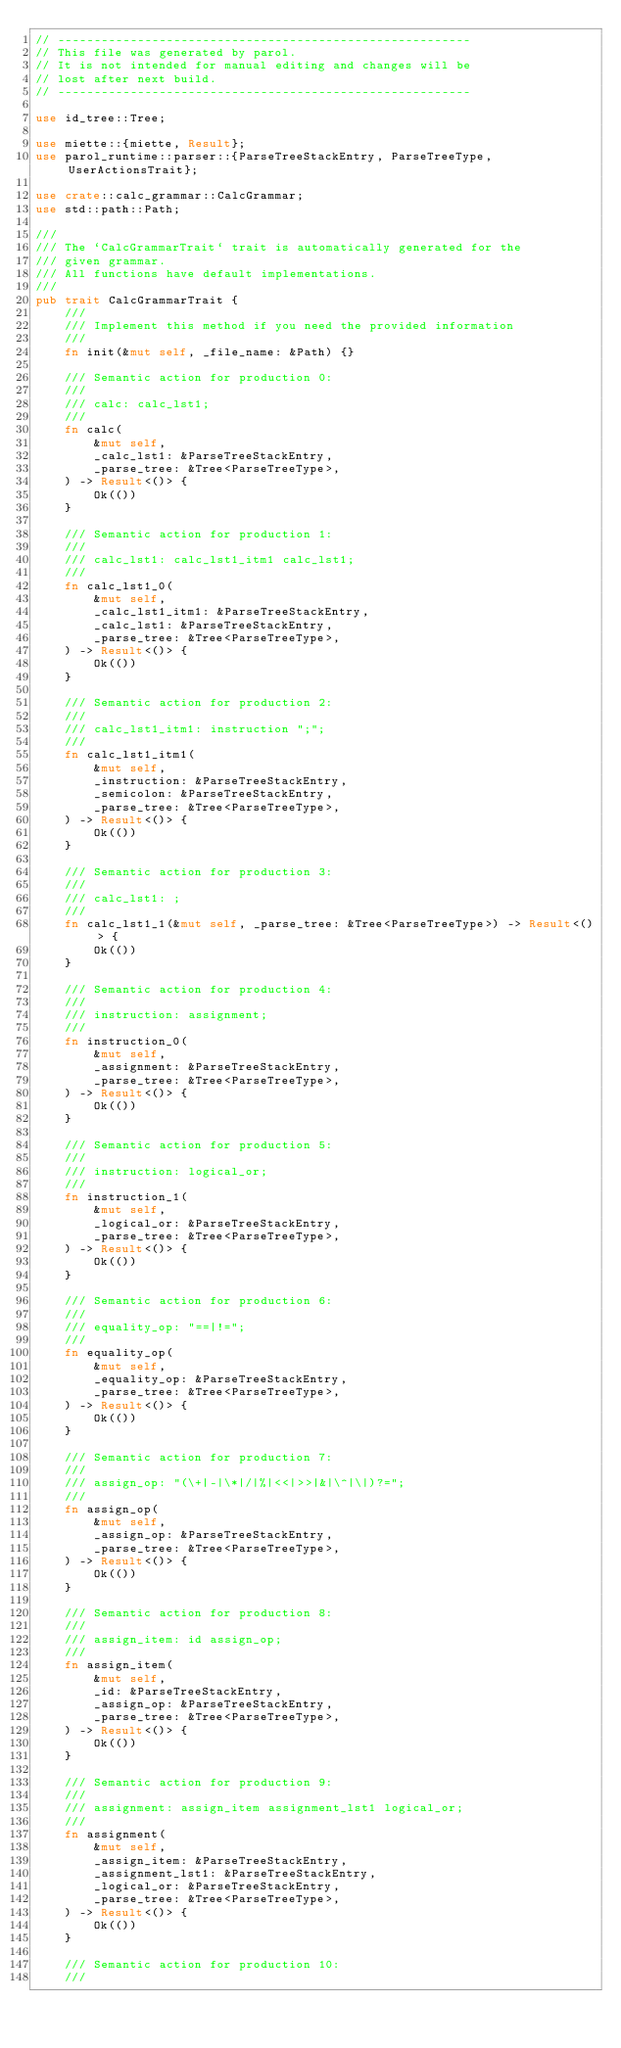Convert code to text. <code><loc_0><loc_0><loc_500><loc_500><_Rust_>// ---------------------------------------------------------
// This file was generated by parol.
// It is not intended for manual editing and changes will be
// lost after next build.
// ---------------------------------------------------------

use id_tree::Tree;

use miette::{miette, Result};
use parol_runtime::parser::{ParseTreeStackEntry, ParseTreeType, UserActionsTrait};

use crate::calc_grammar::CalcGrammar;
use std::path::Path;

///
/// The `CalcGrammarTrait` trait is automatically generated for the
/// given grammar.
/// All functions have default implementations.
///
pub trait CalcGrammarTrait {
    ///
    /// Implement this method if you need the provided information
    ///
    fn init(&mut self, _file_name: &Path) {}

    /// Semantic action for production 0:
    ///
    /// calc: calc_lst1;
    ///
    fn calc(
        &mut self,
        _calc_lst1: &ParseTreeStackEntry,
        _parse_tree: &Tree<ParseTreeType>,
    ) -> Result<()> {
        Ok(())
    }

    /// Semantic action for production 1:
    ///
    /// calc_lst1: calc_lst1_itm1 calc_lst1;
    ///
    fn calc_lst1_0(
        &mut self,
        _calc_lst1_itm1: &ParseTreeStackEntry,
        _calc_lst1: &ParseTreeStackEntry,
        _parse_tree: &Tree<ParseTreeType>,
    ) -> Result<()> {
        Ok(())
    }

    /// Semantic action for production 2:
    ///
    /// calc_lst1_itm1: instruction ";";
    ///
    fn calc_lst1_itm1(
        &mut self,
        _instruction: &ParseTreeStackEntry,
        _semicolon: &ParseTreeStackEntry,
        _parse_tree: &Tree<ParseTreeType>,
    ) -> Result<()> {
        Ok(())
    }

    /// Semantic action for production 3:
    ///
    /// calc_lst1: ;
    ///
    fn calc_lst1_1(&mut self, _parse_tree: &Tree<ParseTreeType>) -> Result<()> {
        Ok(())
    }

    /// Semantic action for production 4:
    ///
    /// instruction: assignment;
    ///
    fn instruction_0(
        &mut self,
        _assignment: &ParseTreeStackEntry,
        _parse_tree: &Tree<ParseTreeType>,
    ) -> Result<()> {
        Ok(())
    }

    /// Semantic action for production 5:
    ///
    /// instruction: logical_or;
    ///
    fn instruction_1(
        &mut self,
        _logical_or: &ParseTreeStackEntry,
        _parse_tree: &Tree<ParseTreeType>,
    ) -> Result<()> {
        Ok(())
    }

    /// Semantic action for production 6:
    ///
    /// equality_op: "==|!=";
    ///
    fn equality_op(
        &mut self,
        _equality_op: &ParseTreeStackEntry,
        _parse_tree: &Tree<ParseTreeType>,
    ) -> Result<()> {
        Ok(())
    }

    /// Semantic action for production 7:
    ///
    /// assign_op: "(\+|-|\*|/|%|<<|>>|&|\^|\|)?=";
    ///
    fn assign_op(
        &mut self,
        _assign_op: &ParseTreeStackEntry,
        _parse_tree: &Tree<ParseTreeType>,
    ) -> Result<()> {
        Ok(())
    }

    /// Semantic action for production 8:
    ///
    /// assign_item: id assign_op;
    ///
    fn assign_item(
        &mut self,
        _id: &ParseTreeStackEntry,
        _assign_op: &ParseTreeStackEntry,
        _parse_tree: &Tree<ParseTreeType>,
    ) -> Result<()> {
        Ok(())
    }

    /// Semantic action for production 9:
    ///
    /// assignment: assign_item assignment_lst1 logical_or;
    ///
    fn assignment(
        &mut self,
        _assign_item: &ParseTreeStackEntry,
        _assignment_lst1: &ParseTreeStackEntry,
        _logical_or: &ParseTreeStackEntry,
        _parse_tree: &Tree<ParseTreeType>,
    ) -> Result<()> {
        Ok(())
    }

    /// Semantic action for production 10:
    ///</code> 